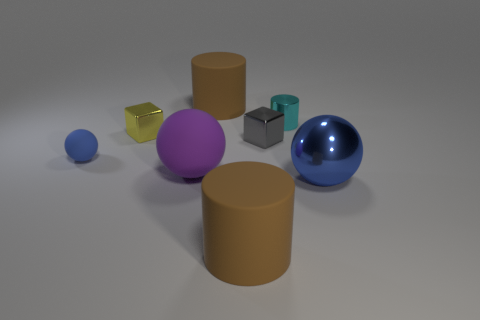Add 1 green cylinders. How many objects exist? 9 Subtract all cylinders. How many objects are left? 5 Subtract all small gray metallic things. Subtract all tiny gray shiny blocks. How many objects are left? 6 Add 5 matte balls. How many matte balls are left? 7 Add 4 matte spheres. How many matte spheres exist? 6 Subtract 1 brown cylinders. How many objects are left? 7 